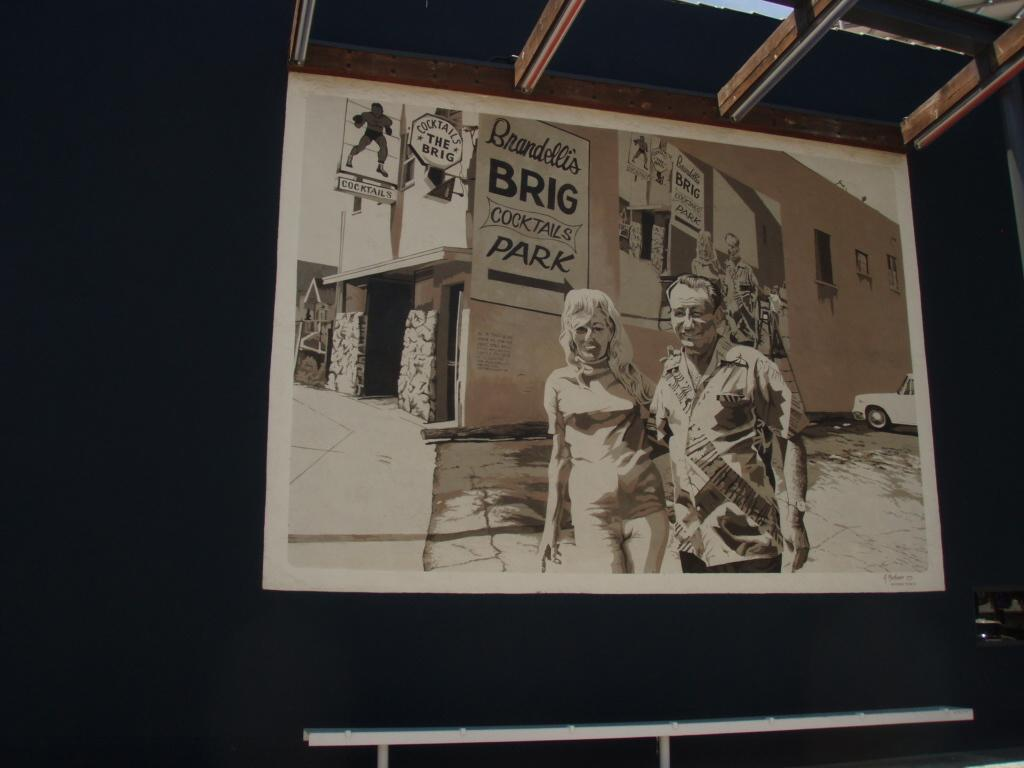<image>
Describe the image concisely. A painting of a couple standing underneath a sign that reads 'Brandelli's Brig Cocktails Park' 